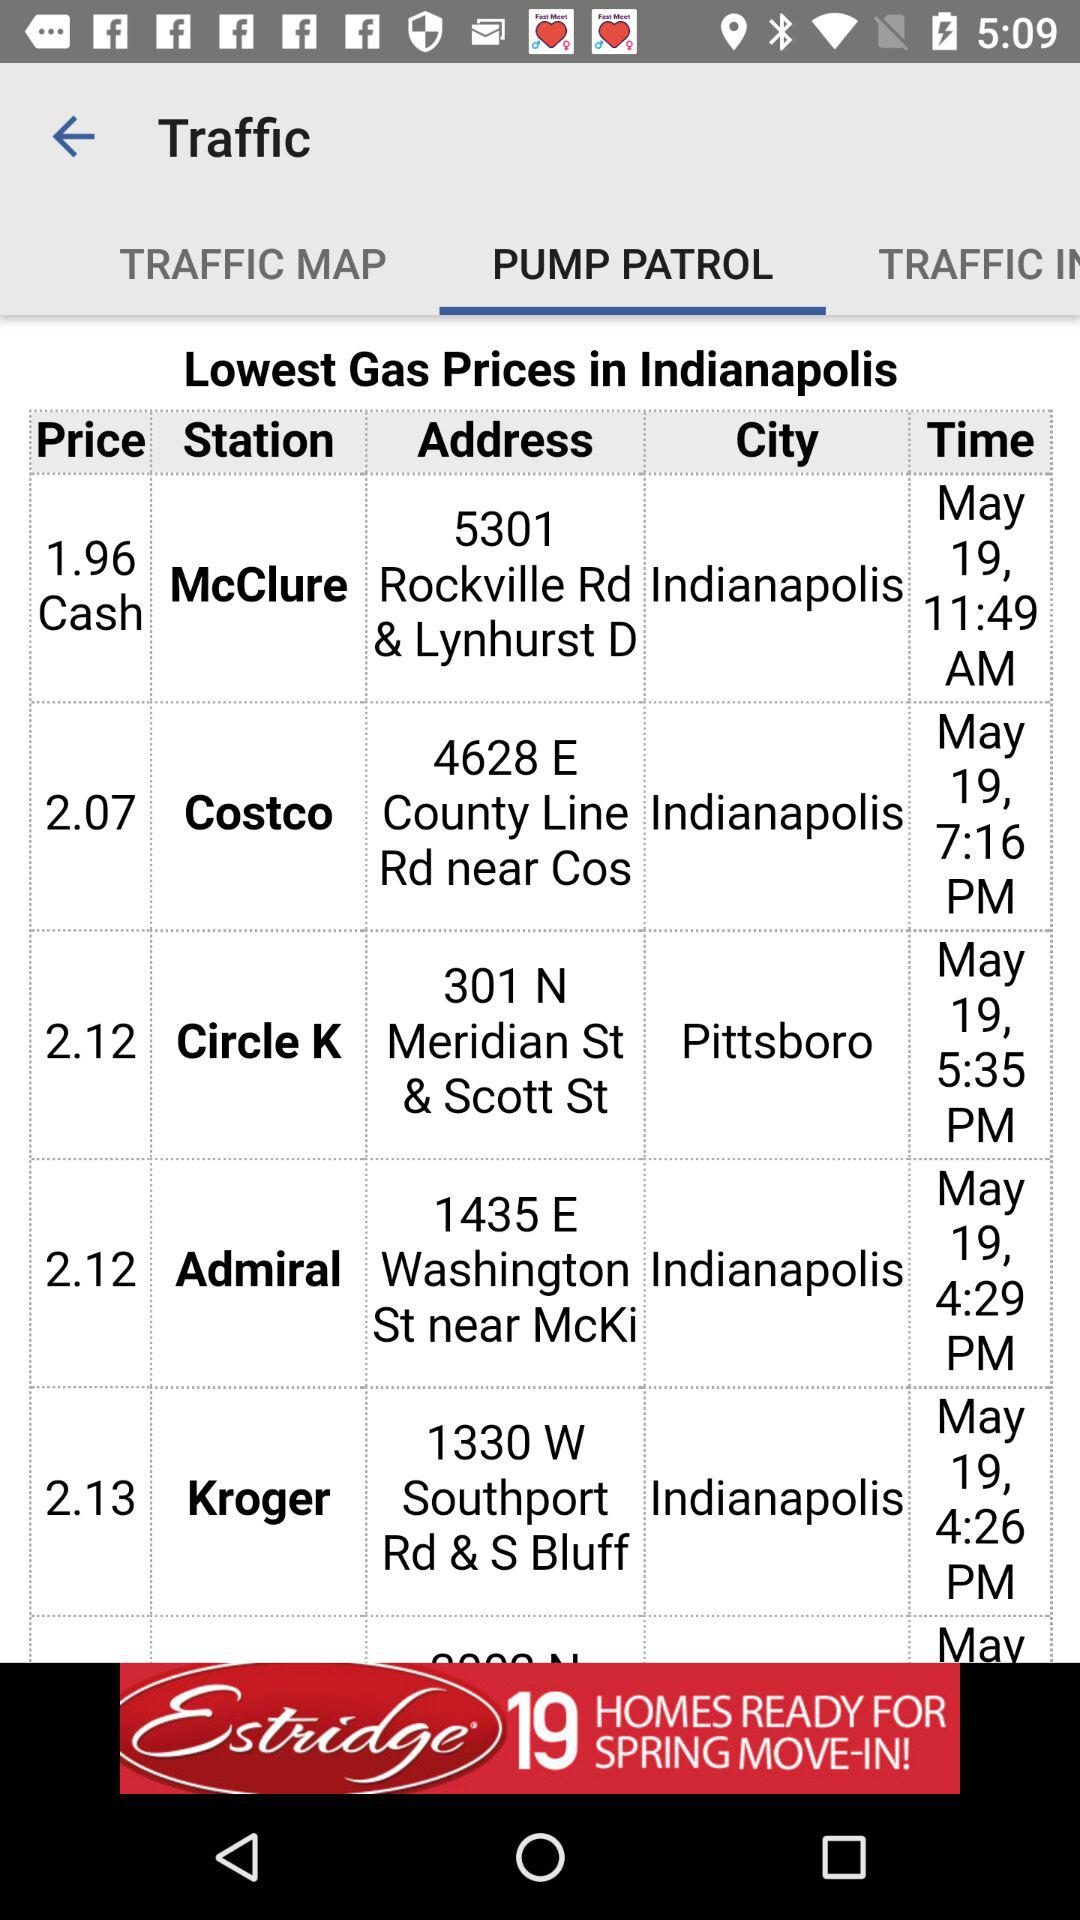What is the address of Costco Station? The address of Costco Station is 4628 E County Line Rd near Cos. 